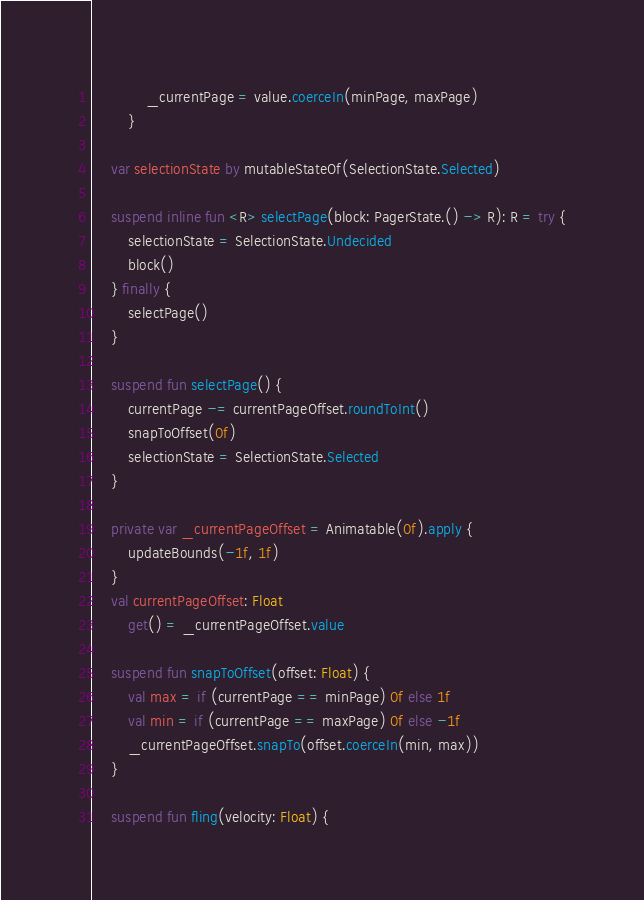<code> <loc_0><loc_0><loc_500><loc_500><_Kotlin_>            _currentPage = value.coerceIn(minPage, maxPage)
        }

    var selectionState by mutableStateOf(SelectionState.Selected)

    suspend inline fun <R> selectPage(block: PagerState.() -> R): R = try {
        selectionState = SelectionState.Undecided
        block()
    } finally {
        selectPage()
    }

    suspend fun selectPage() {
        currentPage -= currentPageOffset.roundToInt()
        snapToOffset(0f)
        selectionState = SelectionState.Selected
    }

    private var _currentPageOffset = Animatable(0f).apply {
        updateBounds(-1f, 1f)
    }
    val currentPageOffset: Float
        get() = _currentPageOffset.value

    suspend fun snapToOffset(offset: Float) {
        val max = if (currentPage == minPage) 0f else 1f
        val min = if (currentPage == maxPage) 0f else -1f
        _currentPageOffset.snapTo(offset.coerceIn(min, max))
    }

    suspend fun fling(velocity: Float) {</code> 